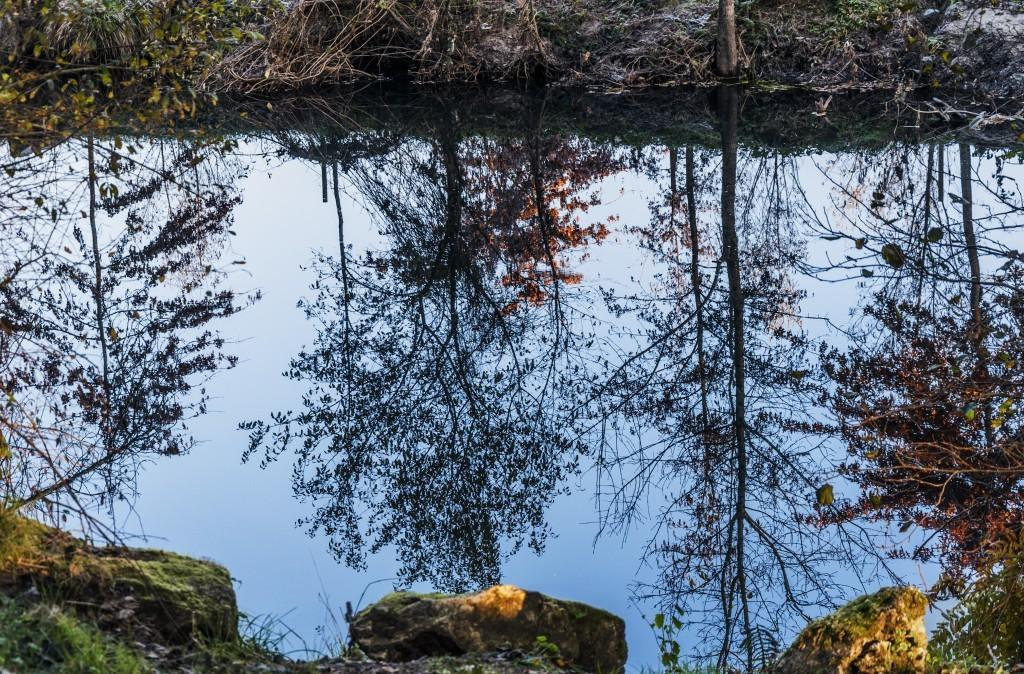What is the primary element visible in the image? There is water in the image. What can be seen in the water due to the reflection? There are reflections of trees in the water. What type of objects are visible near the water? There are stones visible on the side of the water. What type of card is floating on the water in the image? There is no card present in the image; it only features water, reflections of trees, and stones. Can you see a pig swimming in the water in the image? There is no pig present in the image; it only features water, reflections of trees, and stones. 